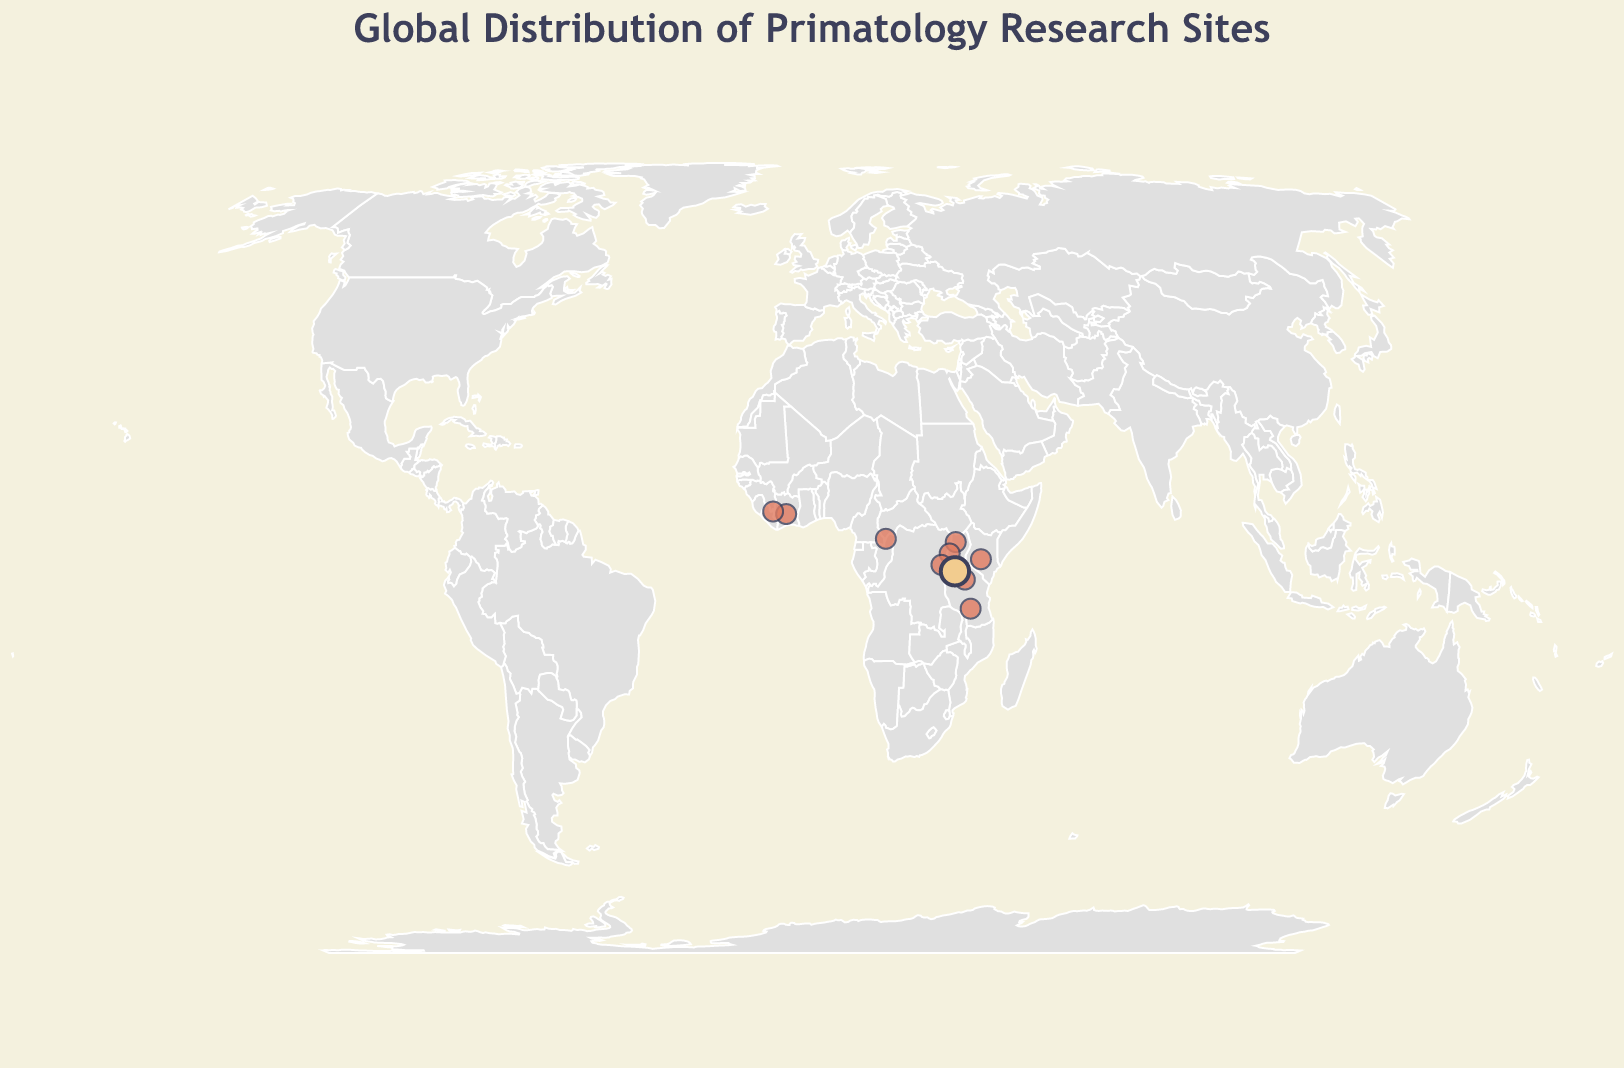What is the title of the figure? The title of the figure is shown at the top with larger text and different color.
Answer: Global Distribution of Primatology Research Sites Which research site is led by Dora Biro? To find the research site led by Dora Biro, look for the data point with Dora Biro listed as the Lead Researcher in the tooltip when you hover over the relevant circle.
Answer: Mahale Mountains National Park How many research sites are focused on chimpanzees? By examining each data point's tooltip and counting those with a Research Focus that mentions 'Chimpanzee', we find five relevant sites: Mahale Mountains National Park, Taï National Park, Budongo Forest Reserve, Gombe Stream National Park, Kibale National Park, Bossou Forest, Ol Pejeta Conservancy, and Issa Valley.
Answer: Eight Which country has the highest number of research sites listed? Count the number of data points for each country. Tanzania appears three times (Mahale Mountains National Park, Gombe Stream National Park, Issa Valley).
Answer: Tanzania What is the primary research focus at Issa Valley? Locate the data point corresponding to Issa Valley in the figure, and check its tooltip for the 'Research_Focus' field.
Answer: Savanna chimpanzees Compare the research focuses of the sites led by Jane Goodall and Dora Biro. Are they the same or different? Look at the tooltips for the sites led by Jane Goodall and Dora Biro. Jane Goodall focuses on Chimpanzee behavior, while Dora Biro focuses on Chimpanzee tool use.
Answer: Different Which research site is the northernmost? By looking at the latitude values of each site, the one with the highest positive value is the northernmost.
Answer: Bossou Forest Determine the average longitude of all the research sites located in Tanzania. Sum the longitudes of Tanzanian sites (31.5728, 33.7833, 35.2167) and divide by the number of sites (3). (31.5728 + 33.7833 + 35.2167) / 3 = 33.5243.
Answer: 33.5243 Identify the lead researcher studying chimpanzee cognition. Find the tooltip for the site with "Chimpanzee cognition" as its Research Focus.
Answer: Tetsuro Matsuzawa What is the color of the data point representing Mahale Mountains National Park? This point is prominently highlighted with a large circle and different color.
Answer: Light yellow (used for Dora Biro's site) 